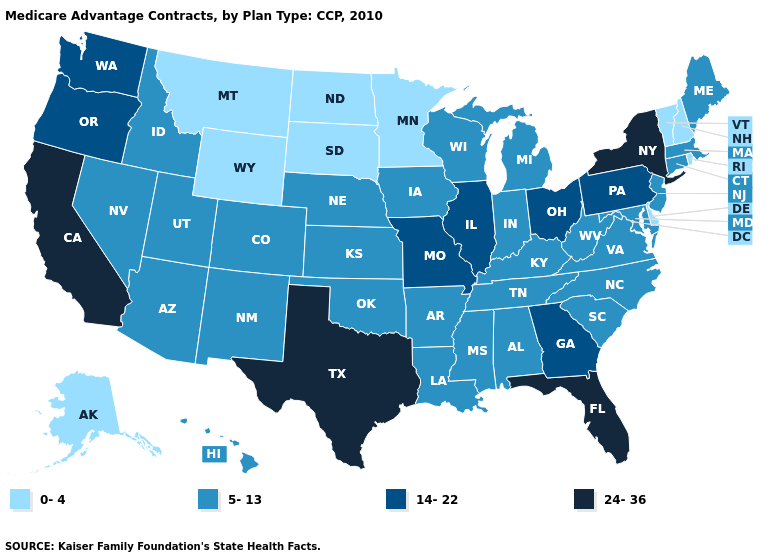Does Maryland have the lowest value in the USA?
Concise answer only. No. What is the lowest value in the Northeast?
Concise answer only. 0-4. What is the value of Georgia?
Answer briefly. 14-22. Name the states that have a value in the range 24-36?
Keep it brief. California, Florida, New York, Texas. Which states have the lowest value in the USA?
Short answer required. Alaska, Delaware, Minnesota, Montana, North Dakota, New Hampshire, Rhode Island, South Dakota, Vermont, Wyoming. Does Connecticut have a lower value than Pennsylvania?
Give a very brief answer. Yes. Among the states that border Ohio , which have the lowest value?
Write a very short answer. Indiana, Kentucky, Michigan, West Virginia. Which states have the lowest value in the USA?
Concise answer only. Alaska, Delaware, Minnesota, Montana, North Dakota, New Hampshire, Rhode Island, South Dakota, Vermont, Wyoming. What is the value of South Carolina?
Quick response, please. 5-13. Which states hav the highest value in the West?
Give a very brief answer. California. Does Montana have the lowest value in the USA?
Be succinct. Yes. What is the value of Montana?
Write a very short answer. 0-4. What is the value of Illinois?
Keep it brief. 14-22. What is the value of Michigan?
Short answer required. 5-13. Which states have the lowest value in the West?
Short answer required. Alaska, Montana, Wyoming. 